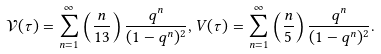<formula> <loc_0><loc_0><loc_500><loc_500>\mathcal { V } ( \tau ) = \sum _ { n = 1 } ^ { \infty } \left ( \frac { n } { 1 3 } \right ) \frac { q ^ { n } } { ( 1 - q ^ { n } ) ^ { 2 } } , V ( \tau ) = \sum _ { n = 1 } ^ { \infty } \left ( \frac { n } { 5 } \right ) \frac { q ^ { n } } { ( 1 - q ^ { n } ) ^ { 2 } } .</formula> 